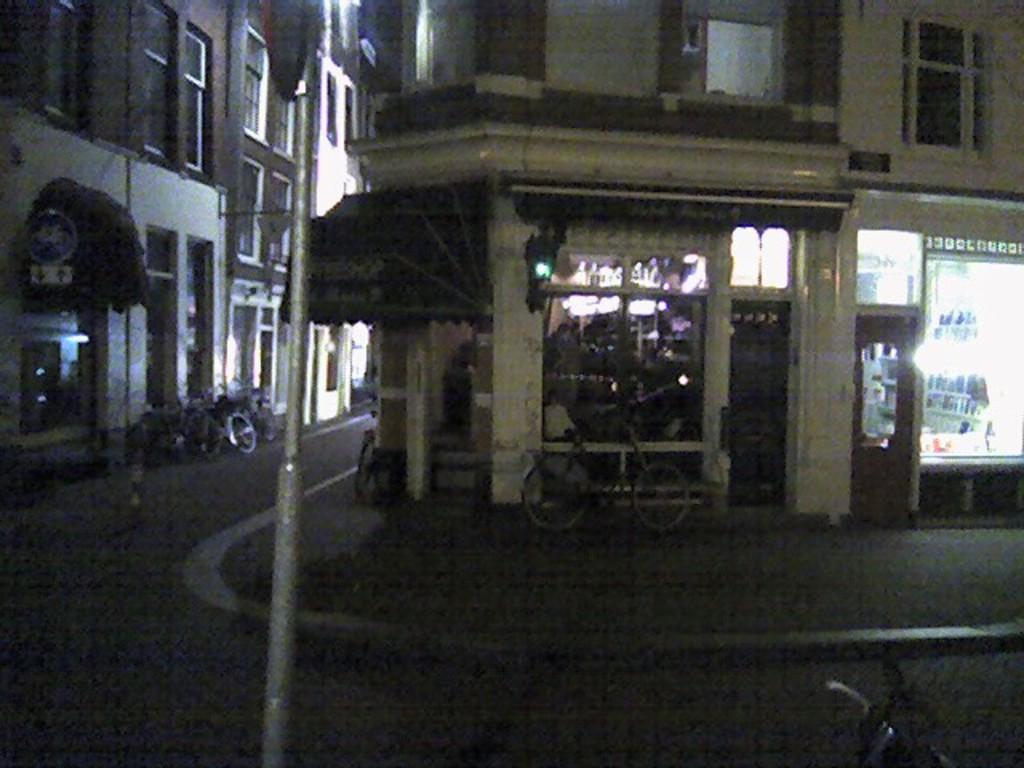Could you give a brief overview of what you see in this image? In this picture there are buildings. In the foreground there is a pole and there are bicycles. On the right side of the image there are lights inside the room. At the bottom there is a road. At the bottom right there is a vehicle. 